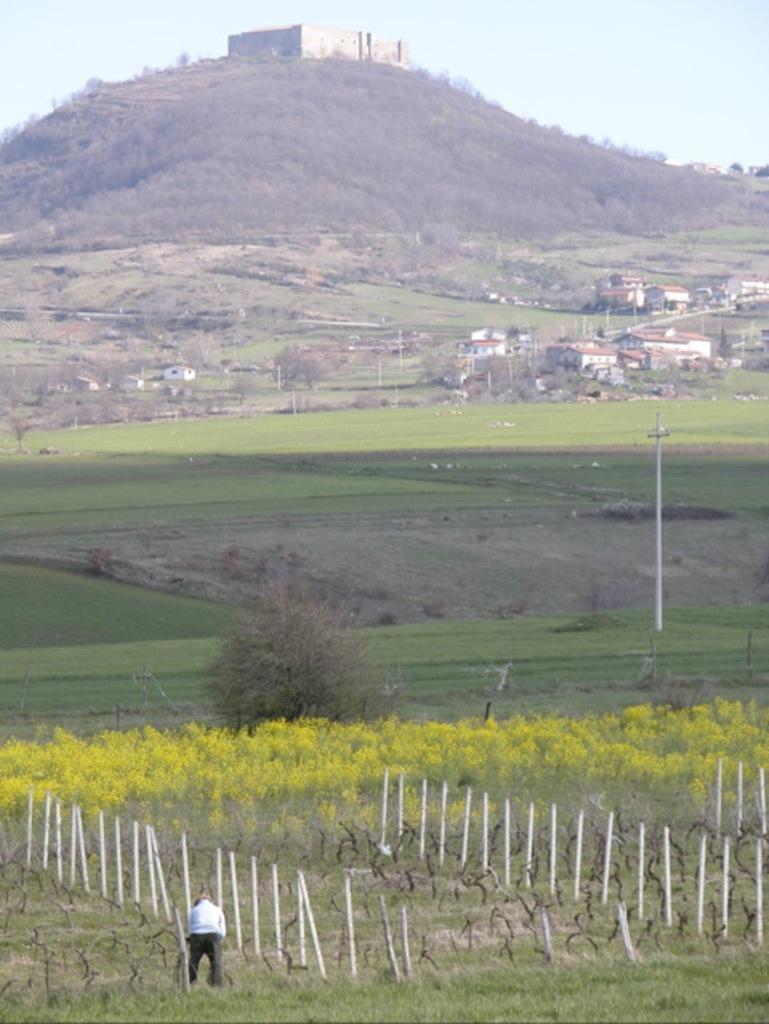Please provide a concise description of this image. There is a person in white color shirt standing on the grass on the ground near poles arranged. In the background, there are plants, trees, grass, houses and poles on the ground, there is a building on the mountain and there is sky. 